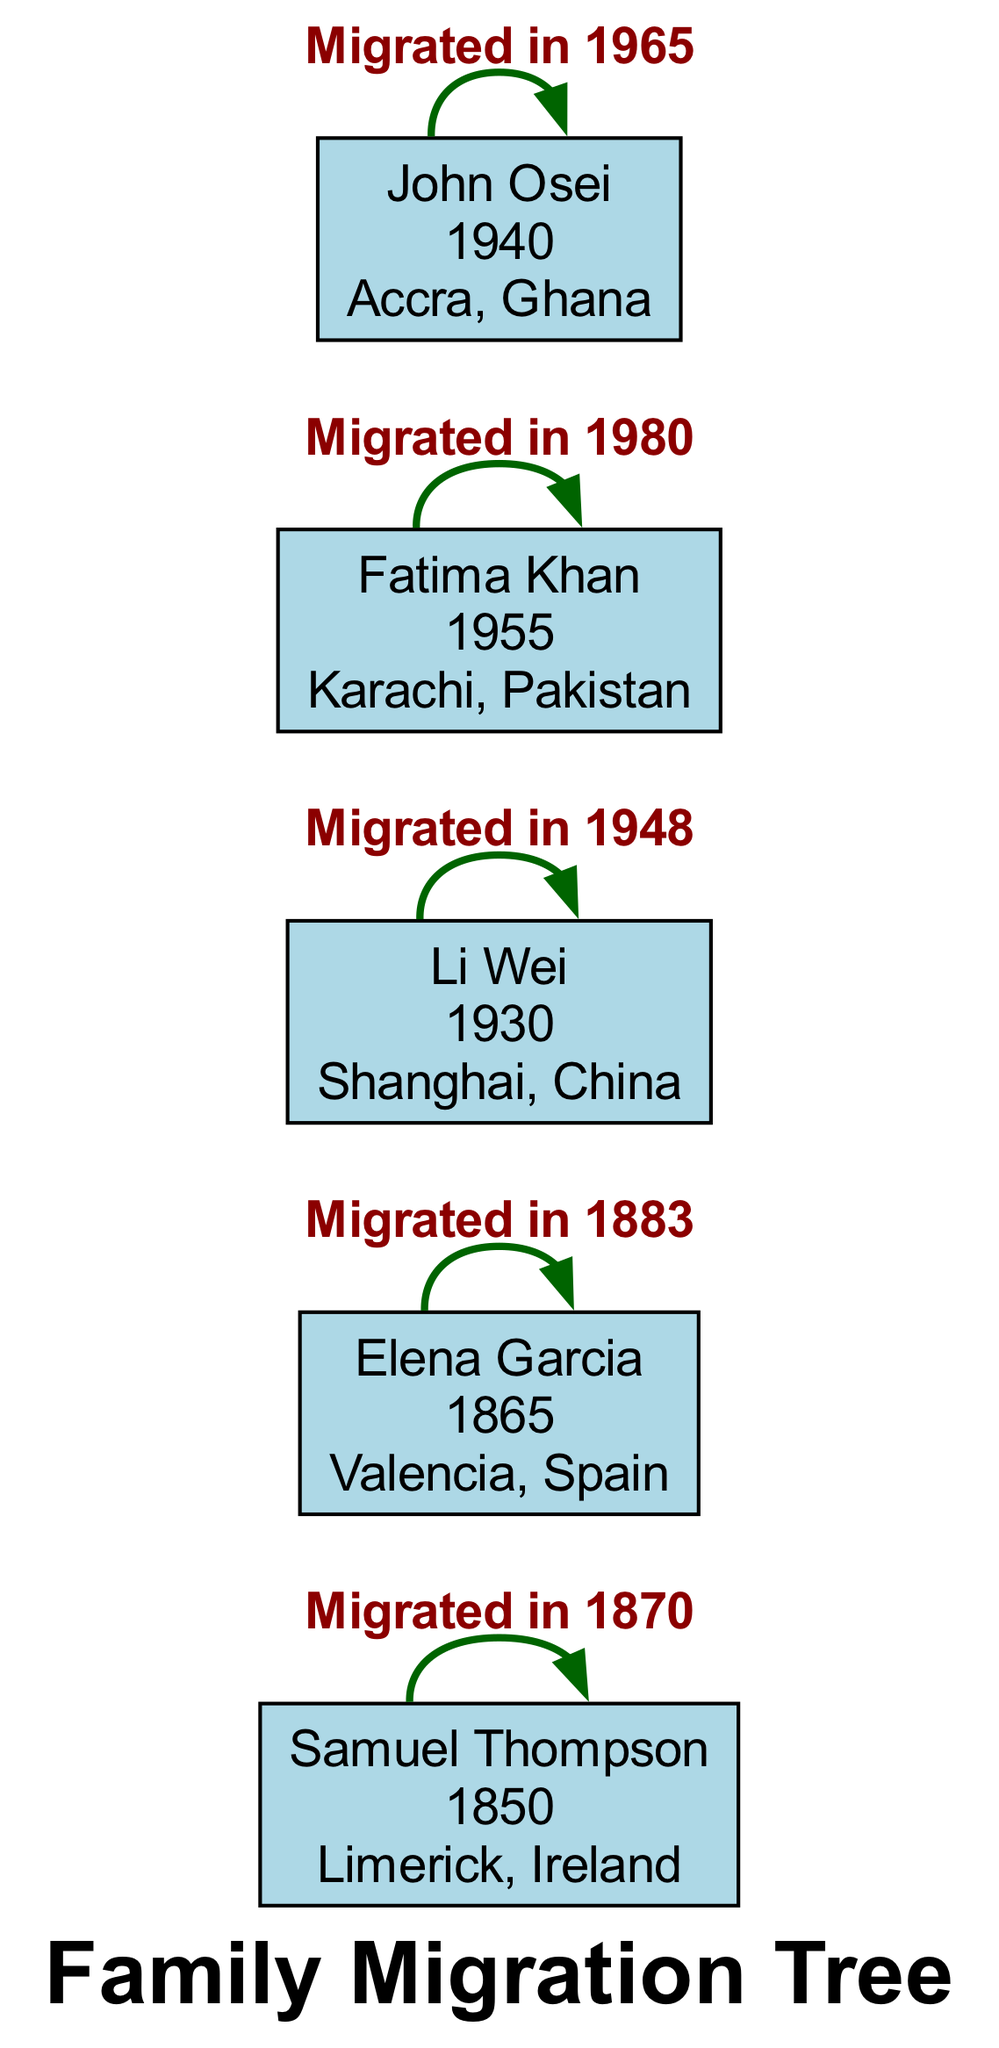What is the birth year of Samuel Thompson? The diagram provides the birth year for Samuel Thompson directly in the node, which states 1850.
Answer: 1850 How many individuals migrated to the USA? By examining the migration patterns in the diagram, we see that there are two individuals: Samuel Thompson from Ireland to Boston and Fatima Khan from Karachi, Pakistan.
Answer: 1 What reason did Elena Garcia migrate? The diagram includes migration reasons in the nodes, revealing that Elena Garcia migrated due to political unrest.
Answer: Political Unrest Which two places are connected through Li Wei's migration? Reviewing Li Wei's information, the diagram shows that Li Wei migrated from Shanghai, China, to Sydney, Australia.
Answer: Shanghai, China to Sydney, Australia Who migrated from Accra, Ghana? The diagram indicates that John Osei is the person who migrated from Accra, Ghana, to London, UK.
Answer: John Osei What year did Fatima Khan migrate? The diagram states that Fatima Khan migrated in 1980, as listed in her node.
Answer: 1980 Between which two locations did Samuel Thompson move? By tracing Samuel Thompson's pathway in the diagram, it shows a migration from Limerick, Ireland, to Boston, USA.
Answer: Limerick, Ireland to Boston, USA How many migration patterns are represented in the diagram? The diagram lists five distinct migration patterns from various original locations to new places, confirming that there are five patterns.
Answer: 5 Which person is associated with the settlement in Buenos Aires? By analyzing the nodes and their respective settlements, the diagram indicates that Elena Garcia settled in Buenos Aires, Argentina.
Answer: Elena Garcia What migration reason is linked to John Osei? In the node of John Osei, the migration reason is explicitly listed as education, indicating the purpose of his move.
Answer: Education 